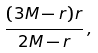<formula> <loc_0><loc_0><loc_500><loc_500>\frac { ( 3 M - r ) r } { 2 M - r } \, ,</formula> 